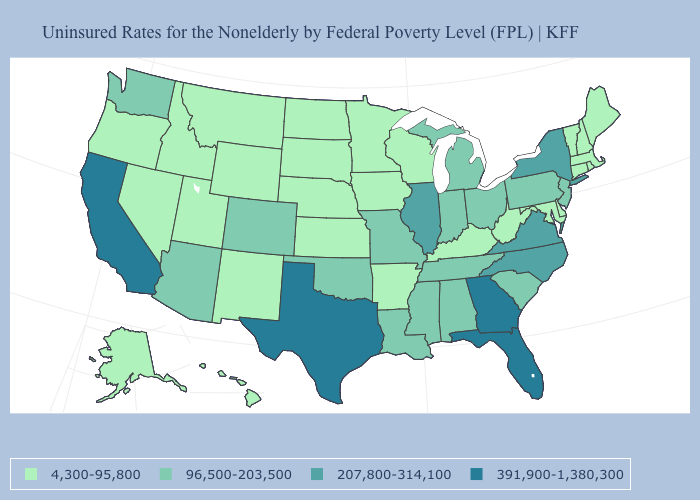Is the legend a continuous bar?
Short answer required. No. Name the states that have a value in the range 96,500-203,500?
Answer briefly. Alabama, Arizona, Colorado, Indiana, Louisiana, Michigan, Mississippi, Missouri, New Jersey, Ohio, Oklahoma, Pennsylvania, South Carolina, Tennessee, Washington. What is the highest value in the West ?
Concise answer only. 391,900-1,380,300. What is the value of Wisconsin?
Concise answer only. 4,300-95,800. Which states have the highest value in the USA?
Answer briefly. California, Florida, Georgia, Texas. Is the legend a continuous bar?
Quick response, please. No. Does Kentucky have the lowest value in the South?
Keep it brief. Yes. How many symbols are there in the legend?
Quick response, please. 4. Name the states that have a value in the range 96,500-203,500?
Short answer required. Alabama, Arizona, Colorado, Indiana, Louisiana, Michigan, Mississippi, Missouri, New Jersey, Ohio, Oklahoma, Pennsylvania, South Carolina, Tennessee, Washington. Which states have the lowest value in the South?
Short answer required. Arkansas, Delaware, Kentucky, Maryland, West Virginia. Among the states that border Kansas , which have the lowest value?
Be succinct. Nebraska. Which states hav the highest value in the South?
Keep it brief. Florida, Georgia, Texas. What is the value of Nebraska?
Give a very brief answer. 4,300-95,800. Name the states that have a value in the range 96,500-203,500?
Quick response, please. Alabama, Arizona, Colorado, Indiana, Louisiana, Michigan, Mississippi, Missouri, New Jersey, Ohio, Oklahoma, Pennsylvania, South Carolina, Tennessee, Washington. 